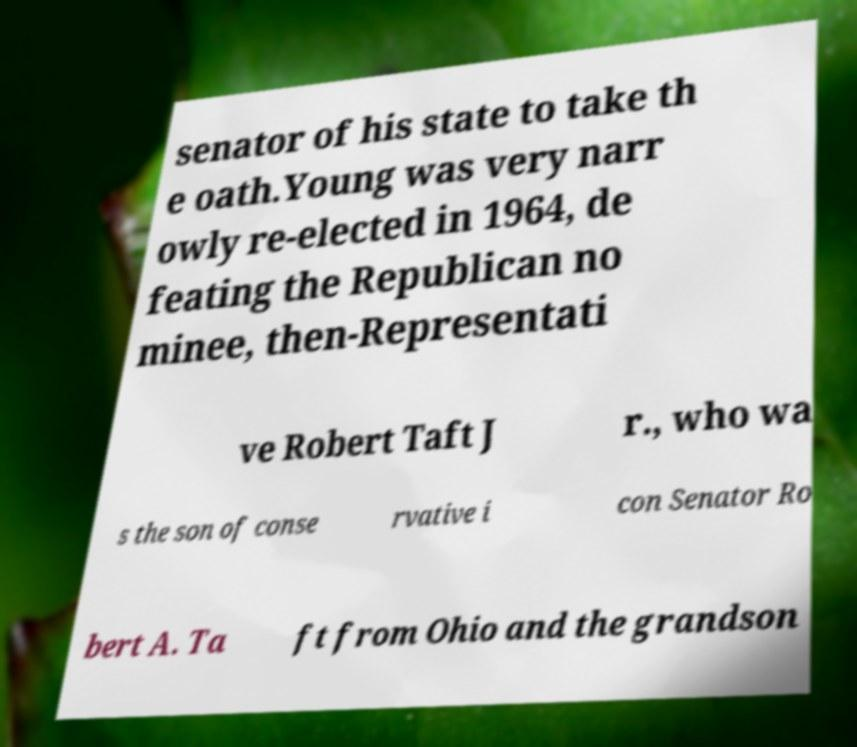I need the written content from this picture converted into text. Can you do that? senator of his state to take th e oath.Young was very narr owly re-elected in 1964, de feating the Republican no minee, then-Representati ve Robert Taft J r., who wa s the son of conse rvative i con Senator Ro bert A. Ta ft from Ohio and the grandson 